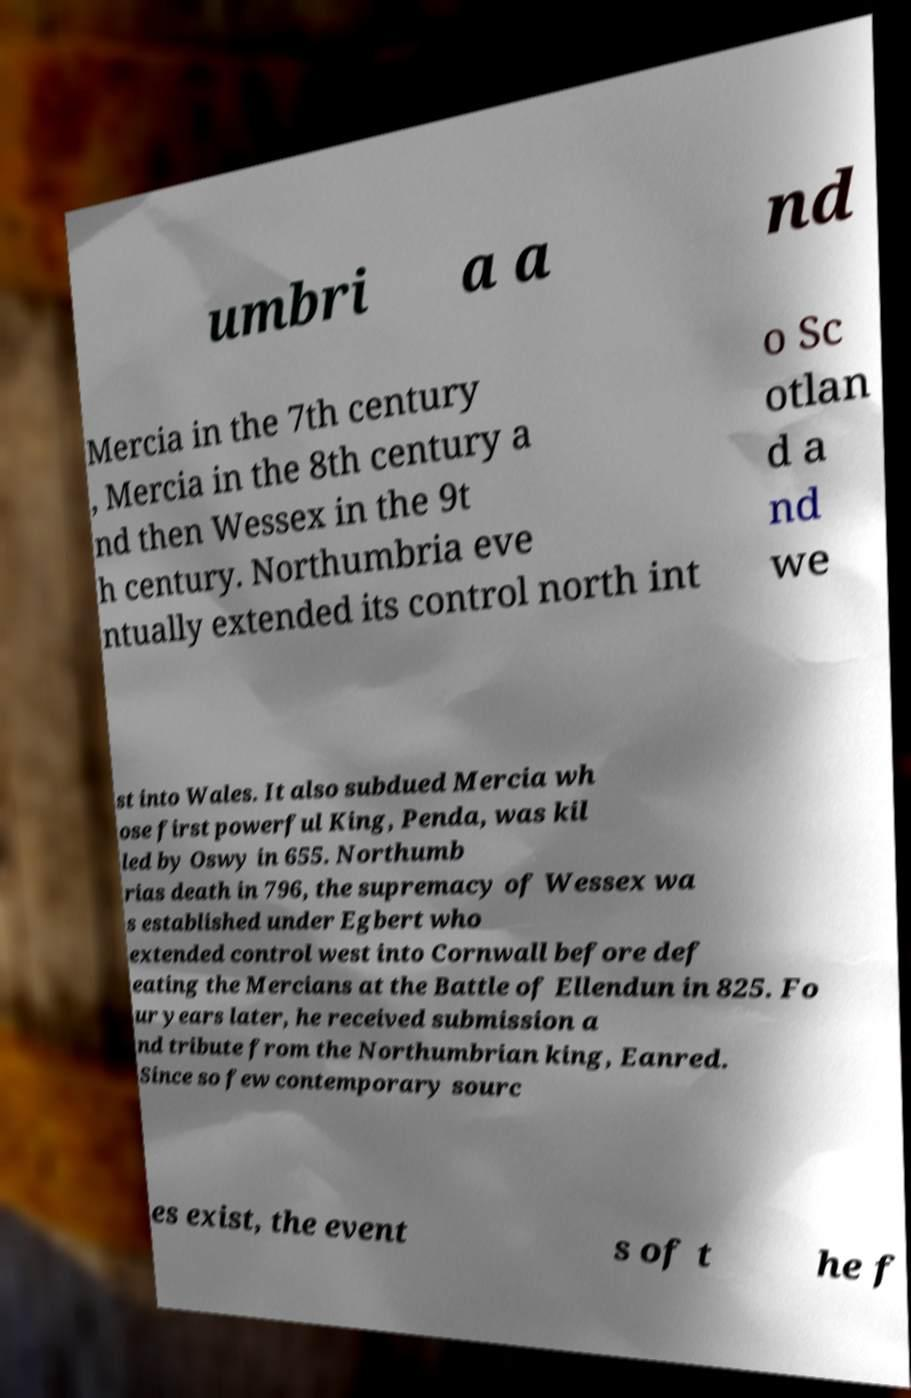Can you accurately transcribe the text from the provided image for me? umbri a a nd Mercia in the 7th century , Mercia in the 8th century a nd then Wessex in the 9t h century. Northumbria eve ntually extended its control north int o Sc otlan d a nd we st into Wales. It also subdued Mercia wh ose first powerful King, Penda, was kil led by Oswy in 655. Northumb rias death in 796, the supremacy of Wessex wa s established under Egbert who extended control west into Cornwall before def eating the Mercians at the Battle of Ellendun in 825. Fo ur years later, he received submission a nd tribute from the Northumbrian king, Eanred. Since so few contemporary sourc es exist, the event s of t he f 